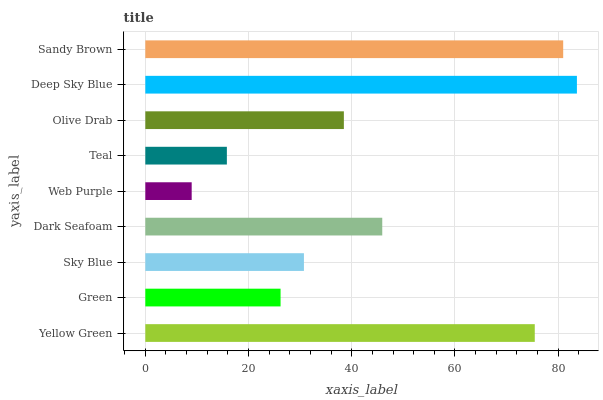Is Web Purple the minimum?
Answer yes or no. Yes. Is Deep Sky Blue the maximum?
Answer yes or no. Yes. Is Green the minimum?
Answer yes or no. No. Is Green the maximum?
Answer yes or no. No. Is Yellow Green greater than Green?
Answer yes or no. Yes. Is Green less than Yellow Green?
Answer yes or no. Yes. Is Green greater than Yellow Green?
Answer yes or no. No. Is Yellow Green less than Green?
Answer yes or no. No. Is Olive Drab the high median?
Answer yes or no. Yes. Is Olive Drab the low median?
Answer yes or no. Yes. Is Yellow Green the high median?
Answer yes or no. No. Is Deep Sky Blue the low median?
Answer yes or no. No. 